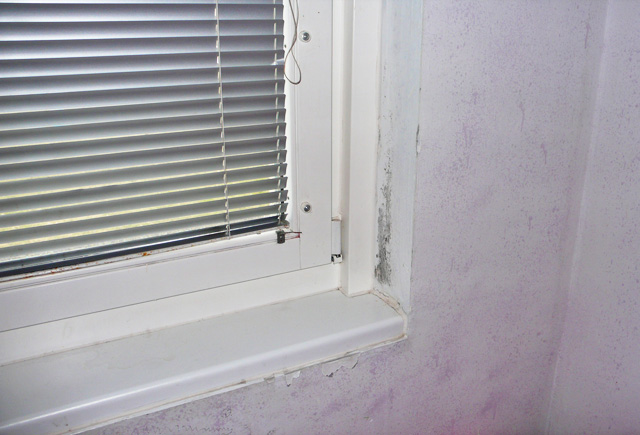what is seen in the photo? The photo shows a window with horizontal blinds. There is visible mold growth on the wall and window frame, which suggests moisture issues and a lack of proper ventilation. The mold is concentrated in the corners and along the edges where condensation is likely to accumulate. This is a common problem in areas with high humidity or where windows are frequently covered, preventing sunlight and air circulation that would normally help keep mold at bay. Addressing the mold problem is important to maintain a healthy indoor environment. 